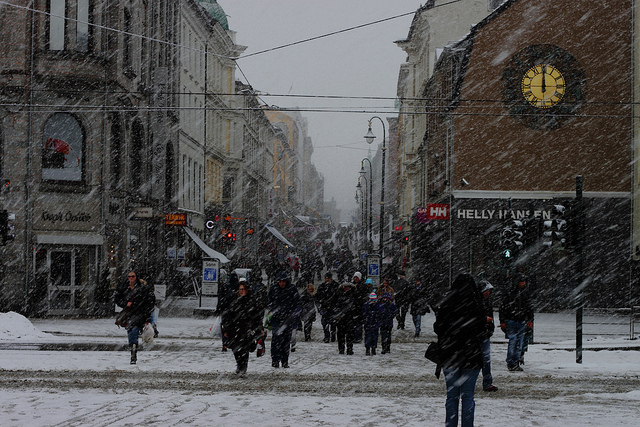<image>What is the name of the building in the background? I am not sure what the name of the building in the background is. It could be 'Helly Hansen' or 'Helly'. What is the name of the building in the background? The name of the building in the background is Helly Hansen. 